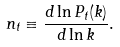<formula> <loc_0><loc_0><loc_500><loc_500>n _ { t } \equiv \frac { d \ln P _ { t } ( k ) } { d \ln k } .</formula> 